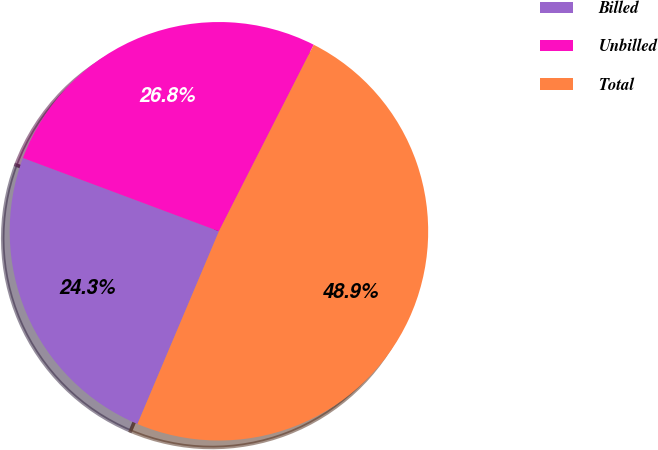Convert chart. <chart><loc_0><loc_0><loc_500><loc_500><pie_chart><fcel>Billed<fcel>Unbilled<fcel>Total<nl><fcel>24.33%<fcel>26.79%<fcel>48.88%<nl></chart> 